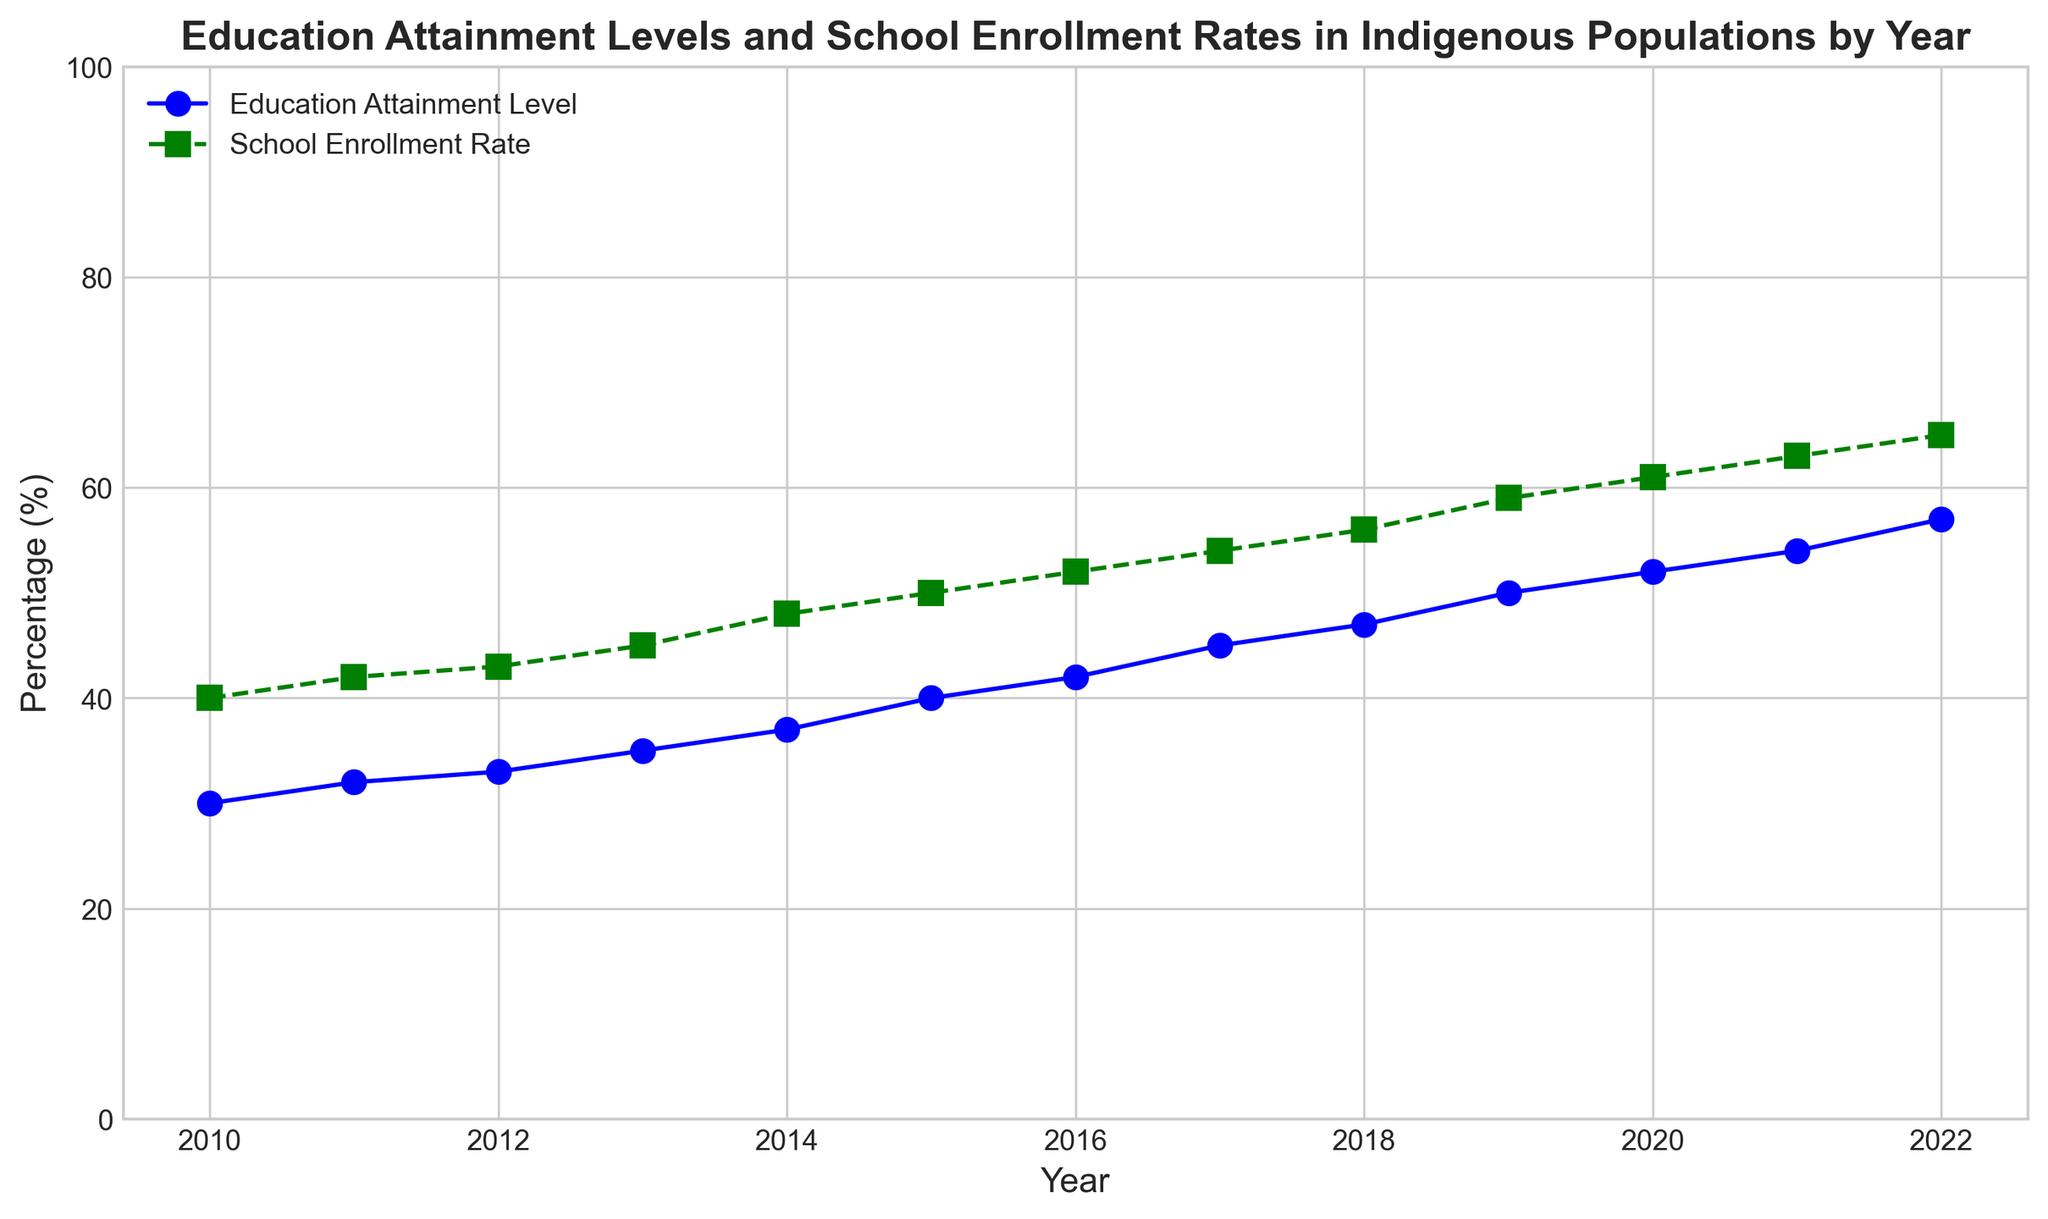What is the difference in the Education Attainment Level between 2010 and 2022? To find the difference in the Education Attainment Level between 2010 and 2022, we look at the respective data points for these years. In 2010, it was 30%, and in 2022, it was 57%. Subtracting these values gives 57% - 30% = 27%.
Answer: 27% How do the rates of School Enrollment and Education Attainment compare in 2015? To compare these rates in 2015, we observe the figure. The School Enrollment Rate is 50%, and the Education Attainment Level is 40%. The School Enrollment Rate is 50% - 40% = 10% higher.
Answer: 10% higher What is the trend in the School Enrollment Rate from 2010 to 2022? To determine the trend, observe the School Enrollment Rate line in the figure. It shows an upward trajectory from 40% in 2010 to 65% in 2022, indicating a consistent increase.
Answer: Increasing In which year is the gap between Education Attainment Level and School Enrollment Rate the smallest? We need to inspect the figure for each year's difference. The smallest gap appears in 2013, where Education Attainment is 35% and Enrollment Rate is 45%, making the gap 45% - 35% = 10%.
Answer: 2013 How much did the Education Attainment Level increase from 2017 to 2021? From the figure, in 2017, Education Attainment Level is 45% and in 2021 it is 54%. The increase is 54% - 45% = 9%.
Answer: 9% What is the average School Enrollment Rate over the period shown in the figure? To find the average, sum the enrollment rates from 2010 to 2022 and divide by the number of years. Sum: 40 + 42 + 43 + 45 + 48 + 50 + 52 + 54 + 56 + 59 + 61 + 63 + 65 = 638. Number of years: 13. Average: 638 / 13 ≈ 49.1%.
Answer: 49.1% Which year saw the greatest single-year increase in Education Attainment Level? Examine the figure for the largest vertical jump in Education Attainment Level. The largest increase is from 2014 to 2015, where it jumps from 37% to 40%, an increase of 40% - 37% = 3%.
Answer: 2015 What is the difference in School Enrollment Rate between 2016 and 2020? The School Enrollment Rate in 2016 is 52%, and in 2020 it is 61%. The difference is 61% - 52% = 9%.
Answer: 9% Which indicator, Education Attainment Level or School Enrollment Rate, has a steeper slope over the entire period shown on the figure? To determine which has a steeper slope, evaluate the overall increase for both indicators from 2010 to 2022. Education Attainment rises from 30% to 57%, an increase of 27%. School Enrollment rises from 40% to 65%, an increase of 25%. Education Attainment has a slightly steeper slope.
Answer: Education Attainment Level 